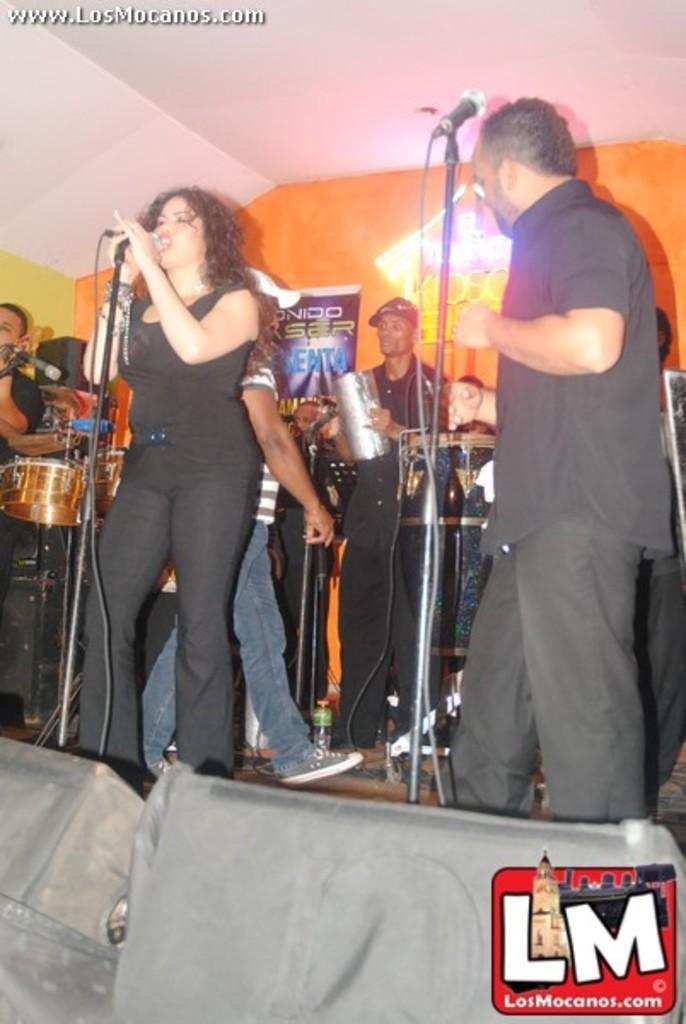Could you give a brief overview of what you see in this image? There is a woman and man singing on a microphone behind them there are so many people playing music instruments. 